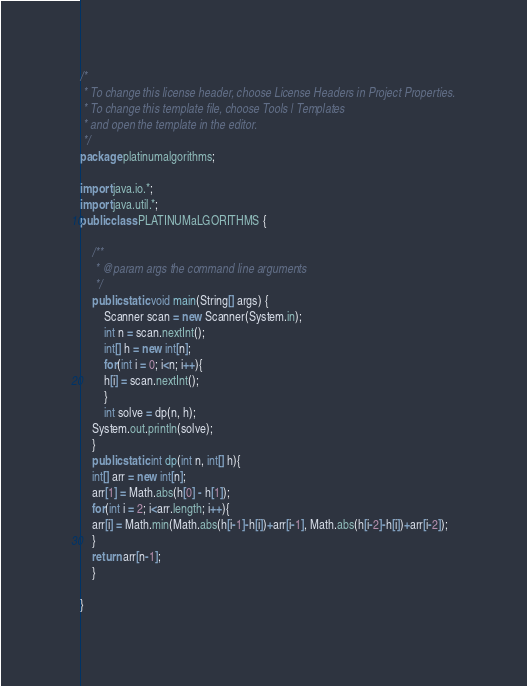<code> <loc_0><loc_0><loc_500><loc_500><_Java_>/*
 * To change this license header, choose License Headers in Project Properties.
 * To change this template file, choose Tools | Templates
 * and open the template in the editor.
 */
package platinumalgorithms;

import java.io.*;
import java.util.*;
public class PLATINUMaLGORITHMS {

    /**
     * @param args the command line arguments
     */
    public static void main(String[] args) {
        Scanner scan = new Scanner(System.in);
        int n = scan.nextInt();
        int[] h = new int[n];
        for(int i = 0; i<n; i++){
        h[i] = scan.nextInt();
        }
        int solve = dp(n, h);
    System.out.println(solve);
    }
    public static int dp(int n, int[] h){
    int[] arr = new int[n];
    arr[1] = Math.abs(h[0] - h[1]);
    for(int i = 2; i<arr.length; i++){
    arr[i] = Math.min(Math.abs(h[i-1]-h[i])+arr[i-1], Math.abs(h[i-2]-h[i])+arr[i-2]);
    }
    return arr[n-1];
    }
    
}
</code> 